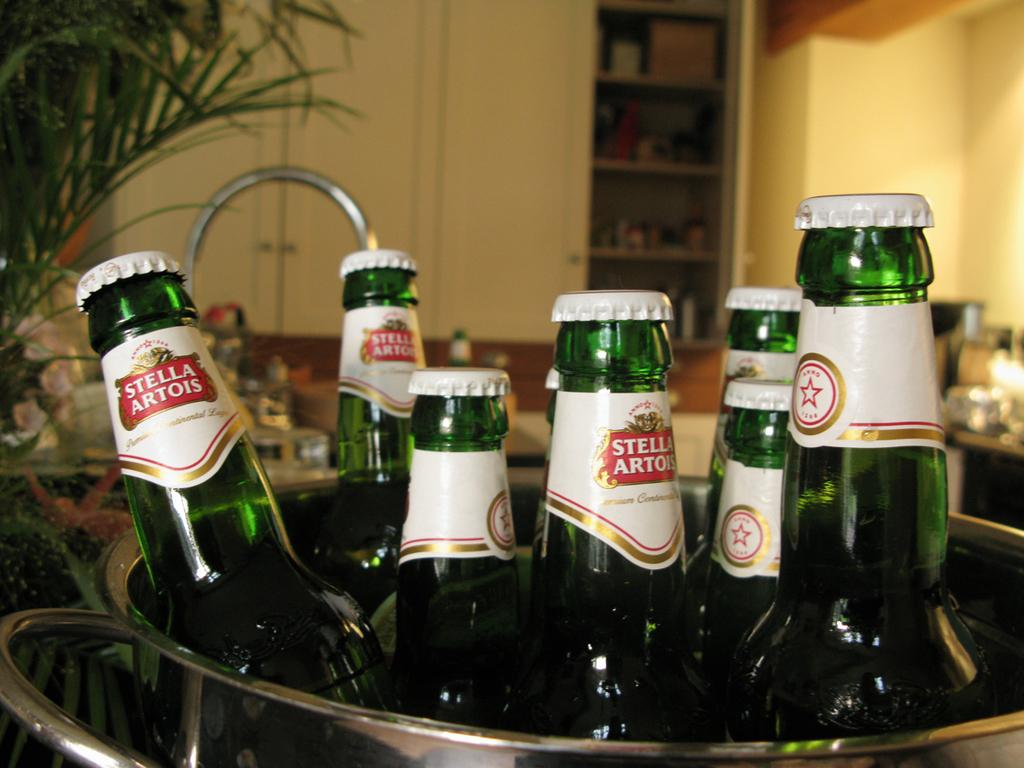Provide a one-sentence caption for the provided image. A bucket filled with six bottles of Stella Artois beer. 